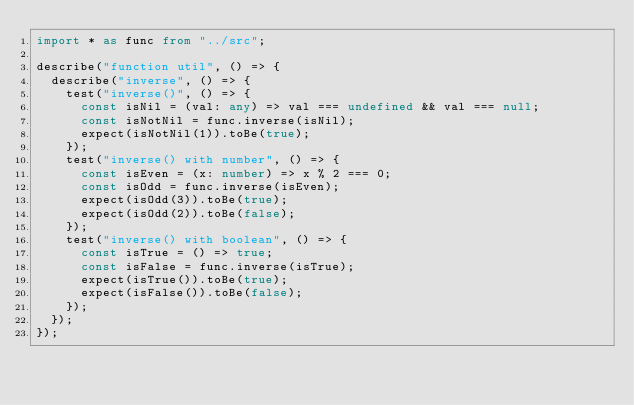<code> <loc_0><loc_0><loc_500><loc_500><_TypeScript_>import * as func from "../src";

describe("function util", () => {
  describe("inverse", () => {
    test("inverse()", () => {
      const isNil = (val: any) => val === undefined && val === null;
      const isNotNil = func.inverse(isNil);
      expect(isNotNil(1)).toBe(true);
    });
    test("inverse() with number", () => {
      const isEven = (x: number) => x % 2 === 0;
      const isOdd = func.inverse(isEven);
      expect(isOdd(3)).toBe(true);
      expect(isOdd(2)).toBe(false);
    });
    test("inverse() with boolean", () => {
      const isTrue = () => true;
      const isFalse = func.inverse(isTrue);
      expect(isTrue()).toBe(true);
      expect(isFalse()).toBe(false);
    });
  });
});
</code> 